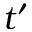<formula> <loc_0><loc_0><loc_500><loc_500>t ^ { \prime }</formula> 